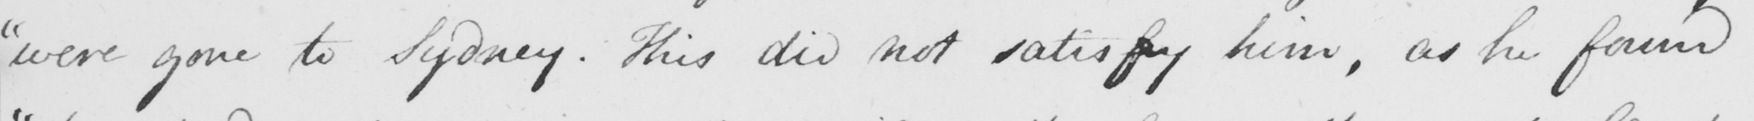Can you read and transcribe this handwriting? " were gone to Sidney . This did not satisfy him , as he found 